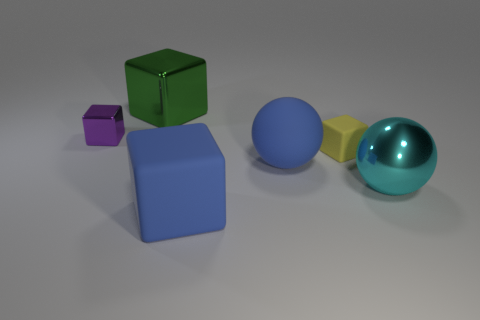Subtract all blue cubes. How many cubes are left? 3 Add 1 tiny yellow rubber blocks. How many objects exist? 7 Subtract all yellow cubes. How many cubes are left? 3 Subtract 2 blocks. How many blocks are left? 2 Subtract all balls. How many objects are left? 4 Add 3 blue objects. How many blue objects exist? 5 Subtract 0 brown cylinders. How many objects are left? 6 Subtract all red spheres. Subtract all red cylinders. How many spheres are left? 2 Subtract all cyan balls. How many cyan cubes are left? 0 Subtract all big matte cylinders. Subtract all large green objects. How many objects are left? 5 